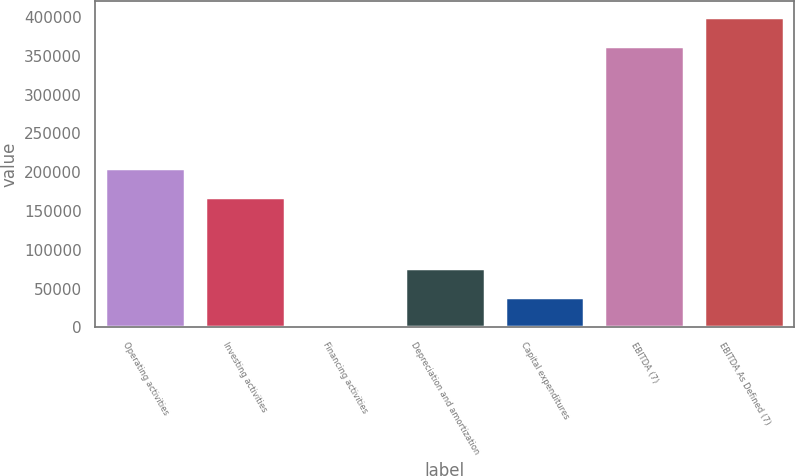<chart> <loc_0><loc_0><loc_500><loc_500><bar_chart><fcel>Operating activities<fcel>Investing activities<fcel>Financing activities<fcel>Depreciation and amortization<fcel>Capital expenditures<fcel>EBITDA (7)<fcel>EBITDA As Defined (7)<nl><fcel>205619<fcel>168388<fcel>2381<fcel>76842.8<fcel>39611.9<fcel>362921<fcel>400152<nl></chart> 